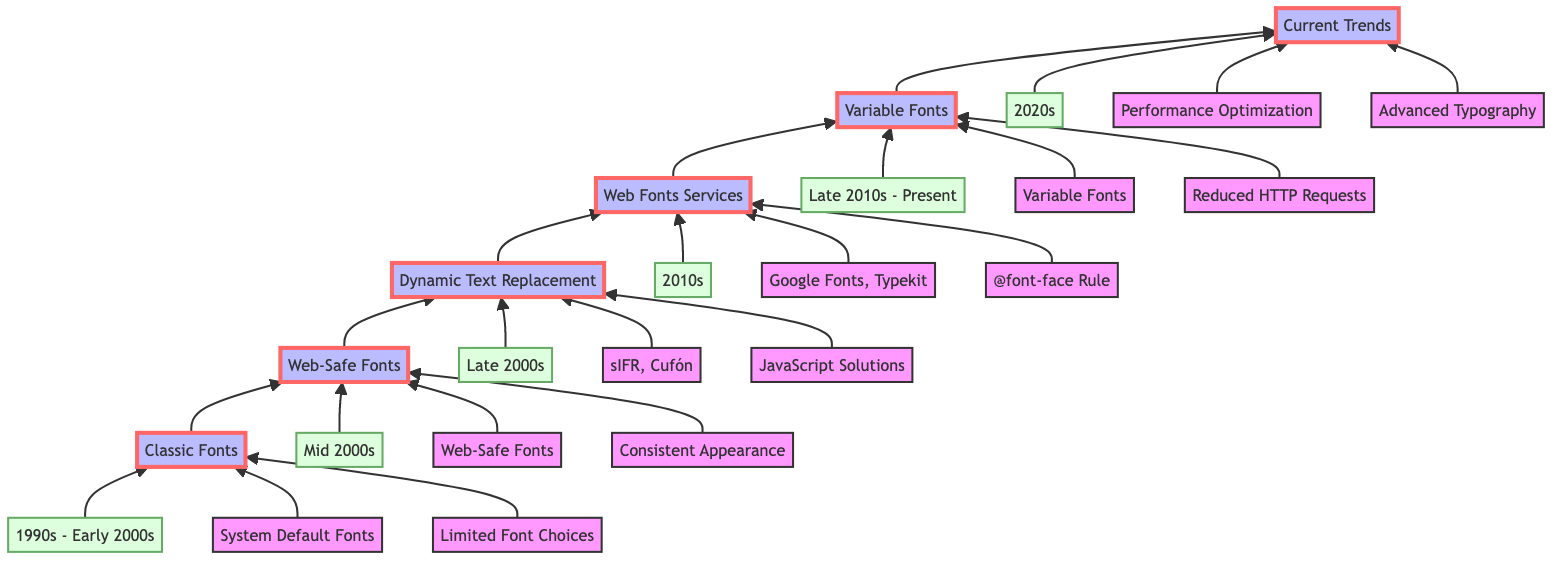What is the earliest level in the diagram? The diagram starts with "Classic Fonts," which is the first level.
Answer: Classic Fonts Which time period is associated with "Web Fonts Services"? "Web Fonts Services" is linked with the time period "2010s," which is indicated by a node pointing towards it.
Answer: 2010s How many key components are listed under "Dynamic Text Replacement"? In the "Dynamic Text Replacement" level, there are three key components mentioned.
Answer: 3 What technique was introduced for custom fonts in the late 2000s? The late 2000s level shows techniques like "sIFR" and "Cufón," which were essential for custom font usage.
Answer: sIFR Which level follows "Web Safe Fonts" in the flow? The flow chart shows that "Dynamic Text Replacement" follows "Web Safe Fonts," connecting them in a sequential manner.
Answer: Dynamic Text Replacement Identify one feature of "Current Trends" in the diagram. The "Current Trends" level describes features such as "Advanced Typography," reflecting modern advancements in web typography.
Answer: Advanced Typography Which two services are mentioned under "Web Fonts Services"? The node specifies "Google Fonts" and "Adobe Typekit" as the two prominent services introduced during the "Web Fonts Services" level.
Answer: Google Fonts, Adobe Typekit What is the main focus of typography in the 2020s according to the diagram? The 2020s focuses on "Performance Optimization," highlighting a critical area of modern web typography practices.
Answer: Performance Optimization What type of fonts were introduced in the late 2010s to the present? The diagram indicates that "Variable Fonts" were introduced during the late 2010s, showing a significant advancement in typography options.
Answer: Variable Fonts 